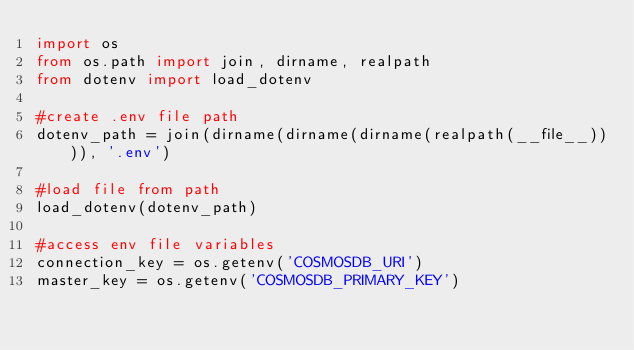<code> <loc_0><loc_0><loc_500><loc_500><_Python_>import os
from os.path import join, dirname, realpath
from dotenv import load_dotenv

#create .env file path
dotenv_path = join(dirname(dirname(dirname(realpath(__file__)))), '.env')

#load file from path
load_dotenv(dotenv_path)

#access env file variables
connection_key = os.getenv('COSMOSDB_URI')
master_key = os.getenv('COSMOSDB_PRIMARY_KEY')</code> 